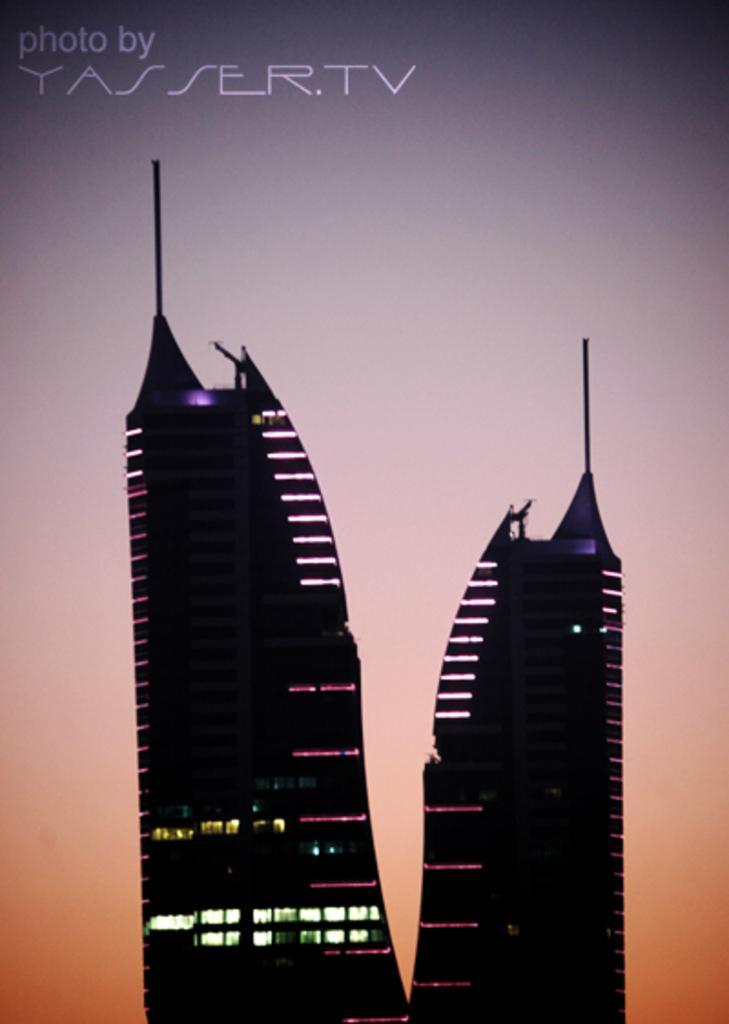How would you summarize this image in a sentence or two? In the picture we can see a tower building with a light and some poles on top of it and it is a photograph and on it is written as TASSER TV. 